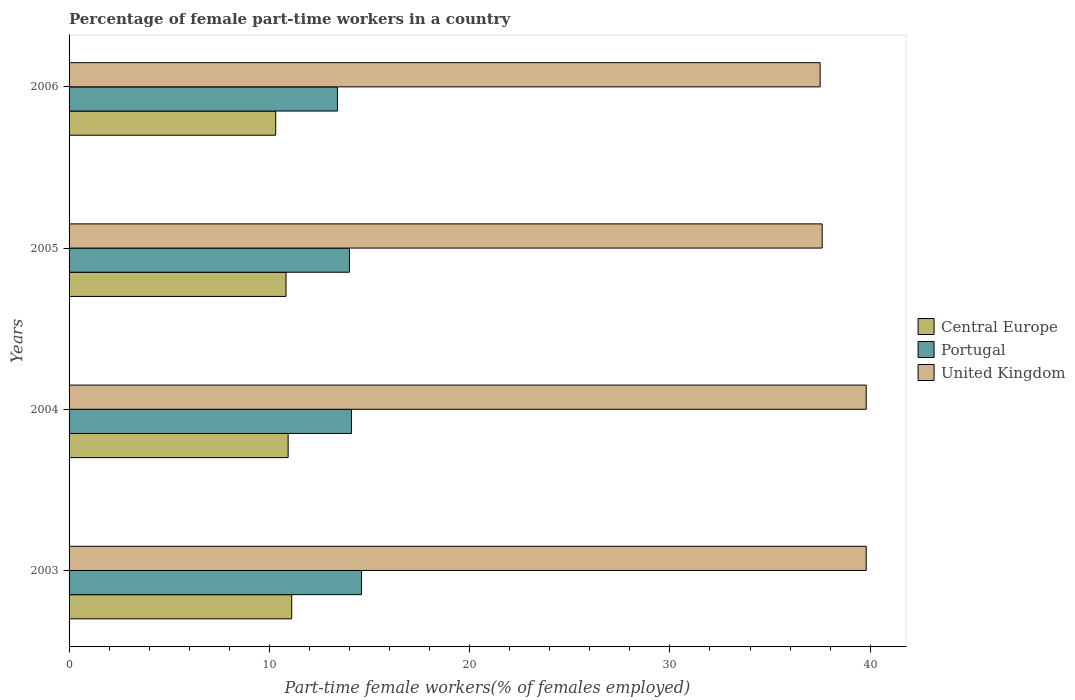How many different coloured bars are there?
Ensure brevity in your answer.  3. How many groups of bars are there?
Keep it short and to the point. 4. Are the number of bars on each tick of the Y-axis equal?
Ensure brevity in your answer.  Yes. How many bars are there on the 3rd tick from the bottom?
Offer a terse response. 3. In how many cases, is the number of bars for a given year not equal to the number of legend labels?
Your response must be concise. 0. What is the percentage of female part-time workers in Central Europe in 2006?
Give a very brief answer. 10.32. Across all years, what is the maximum percentage of female part-time workers in Portugal?
Provide a succinct answer. 14.6. Across all years, what is the minimum percentage of female part-time workers in Portugal?
Provide a succinct answer. 13.4. In which year was the percentage of female part-time workers in United Kingdom minimum?
Your response must be concise. 2006. What is the total percentage of female part-time workers in Central Europe in the graph?
Your answer should be very brief. 43.2. What is the difference between the percentage of female part-time workers in Central Europe in 2003 and that in 2006?
Offer a very short reply. 0.8. What is the difference between the percentage of female part-time workers in United Kingdom in 2006 and the percentage of female part-time workers in Portugal in 2003?
Provide a succinct answer. 22.9. What is the average percentage of female part-time workers in Central Europe per year?
Keep it short and to the point. 10.8. In the year 2004, what is the difference between the percentage of female part-time workers in United Kingdom and percentage of female part-time workers in Central Europe?
Provide a short and direct response. 28.86. What is the ratio of the percentage of female part-time workers in United Kingdom in 2003 to that in 2006?
Offer a very short reply. 1.06. Is the percentage of female part-time workers in Portugal in 2003 less than that in 2004?
Your answer should be very brief. No. What is the difference between the highest and the second highest percentage of female part-time workers in Central Europe?
Make the answer very short. 0.18. What is the difference between the highest and the lowest percentage of female part-time workers in Central Europe?
Ensure brevity in your answer.  0.8. In how many years, is the percentage of female part-time workers in United Kingdom greater than the average percentage of female part-time workers in United Kingdom taken over all years?
Ensure brevity in your answer.  2. What does the 3rd bar from the top in 2005 represents?
Provide a short and direct response. Central Europe. Is it the case that in every year, the sum of the percentage of female part-time workers in United Kingdom and percentage of female part-time workers in Central Europe is greater than the percentage of female part-time workers in Portugal?
Give a very brief answer. Yes. Are the values on the major ticks of X-axis written in scientific E-notation?
Your answer should be very brief. No. Does the graph contain any zero values?
Offer a terse response. No. Does the graph contain grids?
Make the answer very short. No. How are the legend labels stacked?
Provide a succinct answer. Vertical. What is the title of the graph?
Give a very brief answer. Percentage of female part-time workers in a country. What is the label or title of the X-axis?
Your answer should be compact. Part-time female workers(% of females employed). What is the Part-time female workers(% of females employed) in Central Europe in 2003?
Offer a terse response. 11.11. What is the Part-time female workers(% of females employed) of Portugal in 2003?
Make the answer very short. 14.6. What is the Part-time female workers(% of females employed) in United Kingdom in 2003?
Offer a very short reply. 39.8. What is the Part-time female workers(% of females employed) in Central Europe in 2004?
Make the answer very short. 10.94. What is the Part-time female workers(% of females employed) of Portugal in 2004?
Offer a very short reply. 14.1. What is the Part-time female workers(% of females employed) of United Kingdom in 2004?
Give a very brief answer. 39.8. What is the Part-time female workers(% of females employed) of Central Europe in 2005?
Give a very brief answer. 10.83. What is the Part-time female workers(% of females employed) in United Kingdom in 2005?
Keep it short and to the point. 37.6. What is the Part-time female workers(% of females employed) of Central Europe in 2006?
Offer a very short reply. 10.32. What is the Part-time female workers(% of females employed) of Portugal in 2006?
Your answer should be very brief. 13.4. What is the Part-time female workers(% of females employed) of United Kingdom in 2006?
Give a very brief answer. 37.5. Across all years, what is the maximum Part-time female workers(% of females employed) in Central Europe?
Give a very brief answer. 11.11. Across all years, what is the maximum Part-time female workers(% of females employed) in Portugal?
Give a very brief answer. 14.6. Across all years, what is the maximum Part-time female workers(% of females employed) of United Kingdom?
Offer a terse response. 39.8. Across all years, what is the minimum Part-time female workers(% of females employed) in Central Europe?
Offer a very short reply. 10.32. Across all years, what is the minimum Part-time female workers(% of females employed) of Portugal?
Keep it short and to the point. 13.4. Across all years, what is the minimum Part-time female workers(% of females employed) in United Kingdom?
Your answer should be very brief. 37.5. What is the total Part-time female workers(% of females employed) of Central Europe in the graph?
Offer a very short reply. 43.2. What is the total Part-time female workers(% of females employed) in Portugal in the graph?
Provide a short and direct response. 56.1. What is the total Part-time female workers(% of females employed) in United Kingdom in the graph?
Make the answer very short. 154.7. What is the difference between the Part-time female workers(% of females employed) in Central Europe in 2003 and that in 2004?
Offer a terse response. 0.18. What is the difference between the Part-time female workers(% of females employed) of Central Europe in 2003 and that in 2005?
Your answer should be very brief. 0.28. What is the difference between the Part-time female workers(% of females employed) in Portugal in 2003 and that in 2005?
Your response must be concise. 0.6. What is the difference between the Part-time female workers(% of females employed) of Central Europe in 2003 and that in 2006?
Provide a succinct answer. 0.8. What is the difference between the Part-time female workers(% of females employed) in Portugal in 2003 and that in 2006?
Provide a short and direct response. 1.2. What is the difference between the Part-time female workers(% of females employed) of Central Europe in 2004 and that in 2005?
Make the answer very short. 0.11. What is the difference between the Part-time female workers(% of females employed) of Portugal in 2004 and that in 2005?
Give a very brief answer. 0.1. What is the difference between the Part-time female workers(% of females employed) in United Kingdom in 2004 and that in 2005?
Give a very brief answer. 2.2. What is the difference between the Part-time female workers(% of females employed) of Central Europe in 2004 and that in 2006?
Your answer should be compact. 0.62. What is the difference between the Part-time female workers(% of females employed) in Central Europe in 2005 and that in 2006?
Your response must be concise. 0.52. What is the difference between the Part-time female workers(% of females employed) in Central Europe in 2003 and the Part-time female workers(% of females employed) in Portugal in 2004?
Provide a short and direct response. -2.98. What is the difference between the Part-time female workers(% of females employed) in Central Europe in 2003 and the Part-time female workers(% of females employed) in United Kingdom in 2004?
Keep it short and to the point. -28.68. What is the difference between the Part-time female workers(% of females employed) of Portugal in 2003 and the Part-time female workers(% of females employed) of United Kingdom in 2004?
Ensure brevity in your answer.  -25.2. What is the difference between the Part-time female workers(% of females employed) of Central Europe in 2003 and the Part-time female workers(% of females employed) of Portugal in 2005?
Offer a terse response. -2.88. What is the difference between the Part-time female workers(% of females employed) of Central Europe in 2003 and the Part-time female workers(% of females employed) of United Kingdom in 2005?
Provide a short and direct response. -26.48. What is the difference between the Part-time female workers(% of females employed) in Portugal in 2003 and the Part-time female workers(% of females employed) in United Kingdom in 2005?
Ensure brevity in your answer.  -23. What is the difference between the Part-time female workers(% of females employed) in Central Europe in 2003 and the Part-time female workers(% of females employed) in Portugal in 2006?
Your answer should be very brief. -2.29. What is the difference between the Part-time female workers(% of females employed) in Central Europe in 2003 and the Part-time female workers(% of females employed) in United Kingdom in 2006?
Make the answer very short. -26.39. What is the difference between the Part-time female workers(% of females employed) in Portugal in 2003 and the Part-time female workers(% of females employed) in United Kingdom in 2006?
Make the answer very short. -22.9. What is the difference between the Part-time female workers(% of females employed) of Central Europe in 2004 and the Part-time female workers(% of females employed) of Portugal in 2005?
Ensure brevity in your answer.  -3.06. What is the difference between the Part-time female workers(% of females employed) of Central Europe in 2004 and the Part-time female workers(% of females employed) of United Kingdom in 2005?
Your response must be concise. -26.66. What is the difference between the Part-time female workers(% of females employed) in Portugal in 2004 and the Part-time female workers(% of females employed) in United Kingdom in 2005?
Provide a succinct answer. -23.5. What is the difference between the Part-time female workers(% of females employed) in Central Europe in 2004 and the Part-time female workers(% of females employed) in Portugal in 2006?
Your answer should be very brief. -2.46. What is the difference between the Part-time female workers(% of females employed) in Central Europe in 2004 and the Part-time female workers(% of females employed) in United Kingdom in 2006?
Your answer should be compact. -26.56. What is the difference between the Part-time female workers(% of females employed) in Portugal in 2004 and the Part-time female workers(% of females employed) in United Kingdom in 2006?
Provide a succinct answer. -23.4. What is the difference between the Part-time female workers(% of females employed) in Central Europe in 2005 and the Part-time female workers(% of females employed) in Portugal in 2006?
Your answer should be compact. -2.57. What is the difference between the Part-time female workers(% of females employed) in Central Europe in 2005 and the Part-time female workers(% of females employed) in United Kingdom in 2006?
Offer a terse response. -26.67. What is the difference between the Part-time female workers(% of females employed) in Portugal in 2005 and the Part-time female workers(% of females employed) in United Kingdom in 2006?
Your answer should be compact. -23.5. What is the average Part-time female workers(% of females employed) in Portugal per year?
Provide a succinct answer. 14.03. What is the average Part-time female workers(% of females employed) in United Kingdom per year?
Make the answer very short. 38.67. In the year 2003, what is the difference between the Part-time female workers(% of females employed) in Central Europe and Part-time female workers(% of females employed) in Portugal?
Your answer should be very brief. -3.48. In the year 2003, what is the difference between the Part-time female workers(% of females employed) of Central Europe and Part-time female workers(% of females employed) of United Kingdom?
Ensure brevity in your answer.  -28.68. In the year 2003, what is the difference between the Part-time female workers(% of females employed) in Portugal and Part-time female workers(% of females employed) in United Kingdom?
Keep it short and to the point. -25.2. In the year 2004, what is the difference between the Part-time female workers(% of females employed) in Central Europe and Part-time female workers(% of females employed) in Portugal?
Offer a very short reply. -3.16. In the year 2004, what is the difference between the Part-time female workers(% of females employed) of Central Europe and Part-time female workers(% of females employed) of United Kingdom?
Your response must be concise. -28.86. In the year 2004, what is the difference between the Part-time female workers(% of females employed) of Portugal and Part-time female workers(% of females employed) of United Kingdom?
Make the answer very short. -25.7. In the year 2005, what is the difference between the Part-time female workers(% of females employed) of Central Europe and Part-time female workers(% of females employed) of Portugal?
Give a very brief answer. -3.17. In the year 2005, what is the difference between the Part-time female workers(% of females employed) in Central Europe and Part-time female workers(% of females employed) in United Kingdom?
Offer a very short reply. -26.77. In the year 2005, what is the difference between the Part-time female workers(% of females employed) of Portugal and Part-time female workers(% of females employed) of United Kingdom?
Your answer should be very brief. -23.6. In the year 2006, what is the difference between the Part-time female workers(% of females employed) in Central Europe and Part-time female workers(% of females employed) in Portugal?
Ensure brevity in your answer.  -3.08. In the year 2006, what is the difference between the Part-time female workers(% of females employed) in Central Europe and Part-time female workers(% of females employed) in United Kingdom?
Keep it short and to the point. -27.18. In the year 2006, what is the difference between the Part-time female workers(% of females employed) in Portugal and Part-time female workers(% of females employed) in United Kingdom?
Keep it short and to the point. -24.1. What is the ratio of the Part-time female workers(% of females employed) of Central Europe in 2003 to that in 2004?
Your response must be concise. 1.02. What is the ratio of the Part-time female workers(% of females employed) of Portugal in 2003 to that in 2004?
Keep it short and to the point. 1.04. What is the ratio of the Part-time female workers(% of females employed) of Central Europe in 2003 to that in 2005?
Your response must be concise. 1.03. What is the ratio of the Part-time female workers(% of females employed) of Portugal in 2003 to that in 2005?
Provide a succinct answer. 1.04. What is the ratio of the Part-time female workers(% of females employed) of United Kingdom in 2003 to that in 2005?
Provide a short and direct response. 1.06. What is the ratio of the Part-time female workers(% of females employed) of Central Europe in 2003 to that in 2006?
Make the answer very short. 1.08. What is the ratio of the Part-time female workers(% of females employed) of Portugal in 2003 to that in 2006?
Your answer should be very brief. 1.09. What is the ratio of the Part-time female workers(% of females employed) of United Kingdom in 2003 to that in 2006?
Keep it short and to the point. 1.06. What is the ratio of the Part-time female workers(% of females employed) of Central Europe in 2004 to that in 2005?
Offer a terse response. 1.01. What is the ratio of the Part-time female workers(% of females employed) in Portugal in 2004 to that in 2005?
Your answer should be very brief. 1.01. What is the ratio of the Part-time female workers(% of females employed) of United Kingdom in 2004 to that in 2005?
Provide a succinct answer. 1.06. What is the ratio of the Part-time female workers(% of females employed) of Central Europe in 2004 to that in 2006?
Give a very brief answer. 1.06. What is the ratio of the Part-time female workers(% of females employed) in Portugal in 2004 to that in 2006?
Your answer should be compact. 1.05. What is the ratio of the Part-time female workers(% of females employed) in United Kingdom in 2004 to that in 2006?
Provide a short and direct response. 1.06. What is the ratio of the Part-time female workers(% of females employed) in Portugal in 2005 to that in 2006?
Provide a succinct answer. 1.04. What is the difference between the highest and the second highest Part-time female workers(% of females employed) of Central Europe?
Make the answer very short. 0.18. What is the difference between the highest and the lowest Part-time female workers(% of females employed) of Central Europe?
Provide a short and direct response. 0.8. What is the difference between the highest and the lowest Part-time female workers(% of females employed) in Portugal?
Offer a very short reply. 1.2. What is the difference between the highest and the lowest Part-time female workers(% of females employed) in United Kingdom?
Offer a very short reply. 2.3. 